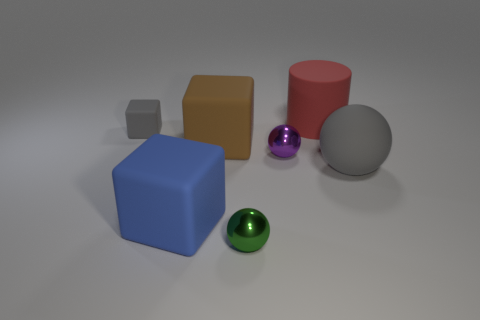There is a large ball that is the same color as the tiny block; what is its material?
Give a very brief answer. Rubber. How many objects are gray rubber things that are to the right of the large cylinder or big cyan shiny cylinders?
Offer a terse response. 1. There is a gray rubber object that is to the left of the green sphere; does it have the same size as the big red object?
Provide a short and direct response. No. Are there fewer big brown objects right of the large ball than large metal cubes?
Provide a short and direct response. No. There is a ball that is the same size as the red cylinder; what material is it?
Offer a terse response. Rubber. How many big things are either blue cubes or rubber spheres?
Give a very brief answer. 2. How many objects are either rubber balls that are right of the small purple metallic ball or things that are in front of the small rubber block?
Offer a very short reply. 5. Are there fewer small purple rubber cylinders than small green metal balls?
Your answer should be compact. Yes. The green metal thing that is the same size as the purple metal thing is what shape?
Ensure brevity in your answer.  Sphere. How many other things are there of the same color as the tiny rubber block?
Offer a very short reply. 1. 